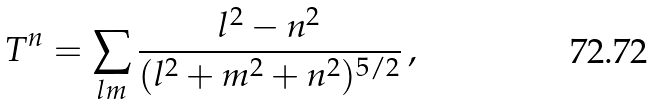<formula> <loc_0><loc_0><loc_500><loc_500>T ^ { n } = \sum _ { l m } \frac { l ^ { 2 } - n ^ { 2 } } { ( l ^ { 2 } + m ^ { 2 } + n ^ { 2 } ) ^ { 5 / 2 } } \, ,</formula> 